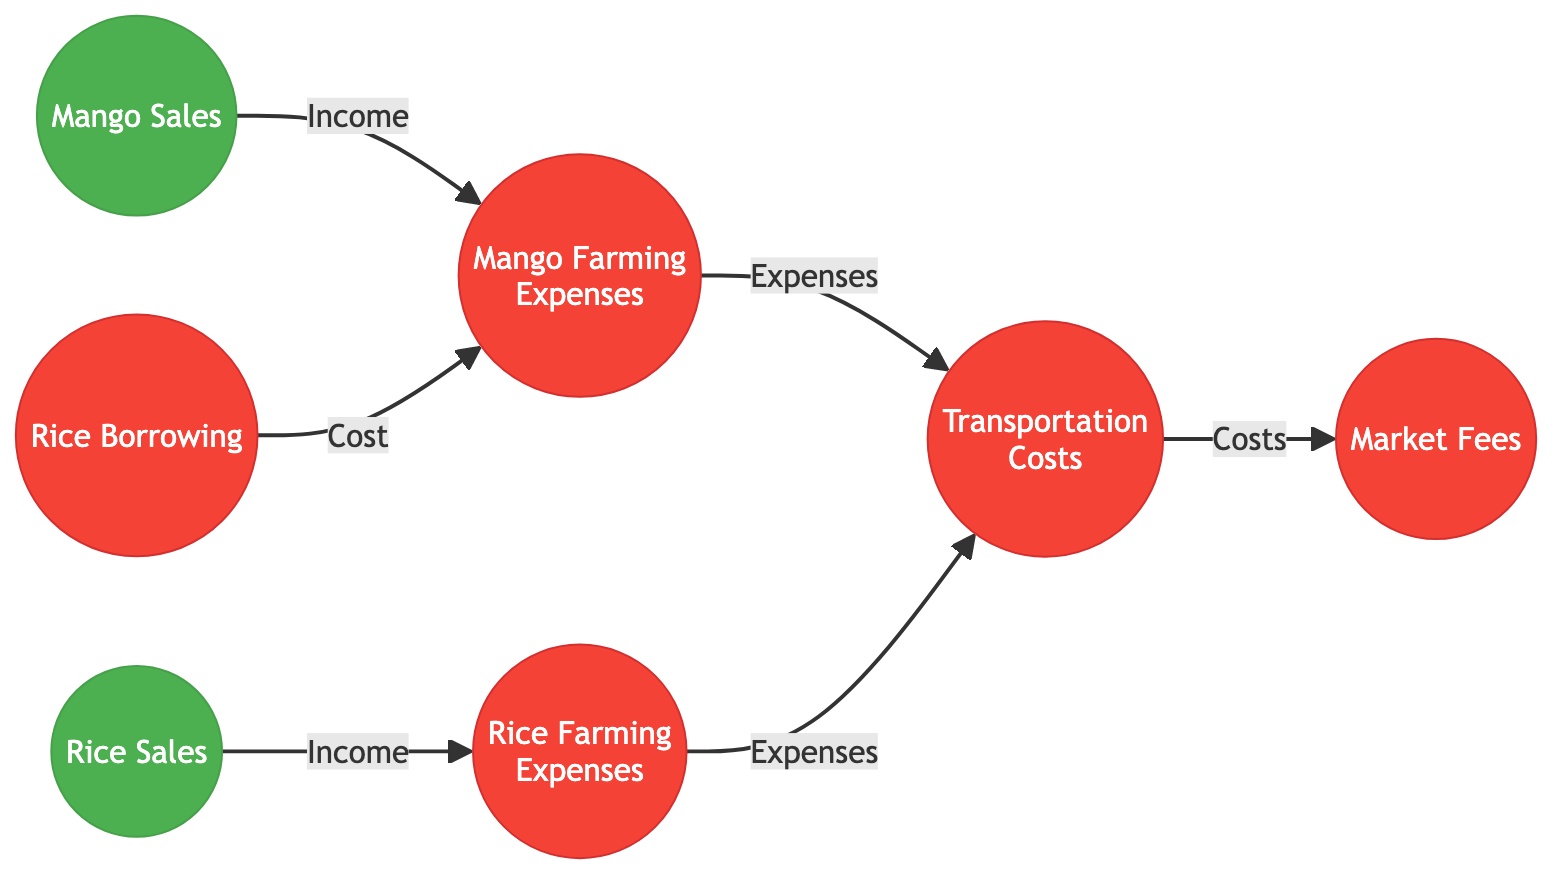What are the expenses related to mango farming? The diagram indicates that the expenses related to mango farming include "Mango Farming Expenses," which accounts for various costs such as labor, fertilizers, and irrigation.
Answer: Mango Farming Expenses How many revenue nodes are present in the diagram? By counting the nodes marked as revenue, we identify two: "Mango Sales" and "Rice Sales." Thus, the total number of revenue nodes is 2.
Answer: 2 What is the relationship between Mango Sales and Transportation Costs? According to the flow in the diagram, the connection shows that "Mango Sales" contributes Income to "Mango Farming Expenses," which then leads to "Transportation Costs" through expenses.
Answer: Income Which expense is directly linked to Rice Sales? The diagram highlights that "Rice Sales" generates Income, which directly leads to "Rice Farming Expenses." Thus, the related expense is "Rice Farming Expenses."
Answer: Rice Farming Expenses What does Rice Borrowing contribute to in the graph? The arrow from "Rice Borrowing" points to "Mango Farming Expenses," indicating that it contributes as a cost to that expense category.
Answer: Cost What node is affected by both Mango Farming Expenses and Rice Farming Expenses? The "Transportation Costs" node is affected by both "Mango Farming Expenses" and "Rice Farming Expenses," as both contribute expenses to transportation.
Answer: Transportation Costs What is the final expense after Transportation Costs in the diagram flow? From "Transportation Costs," there is an outgoing link to "Market Fees," meaning that "Market Fees" is the final expense in this flow.
Answer: Market Fees Which type of expense has a direct link to Rice Farming? In the diagram, "Rice Farming Expenses" is directly linked to "Rice Sales," thus it is the expense type that has a direct flow related to rice farming.
Answer: Rice Farming Expenses What is the total number of nodes in the diagram? Counting all individual nodes presented, including revenues and expenses, we find the total number of nodes is 7.
Answer: 7 